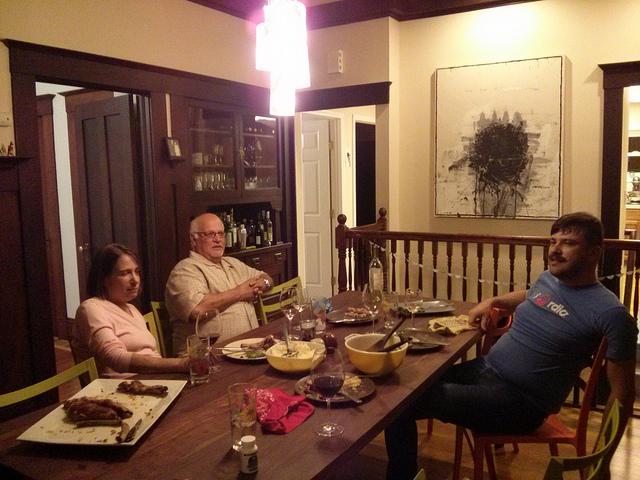Is the man with the brown hair wearing a tight shirt or a loose shirt?
Concise answer only. Tight. How many of the diners are overweight?
Concise answer only. 3. Where are these people sitting?
Be succinct. At table. Who is wearing a white blouse?
Quick response, please. Woman. What are they doing?
Write a very short answer. Eating. How many people are in this picture?
Write a very short answer. 3. What do the people have in their hands?
Concise answer only. Nothing. Does the woman look happy?
Answer briefly. No. 